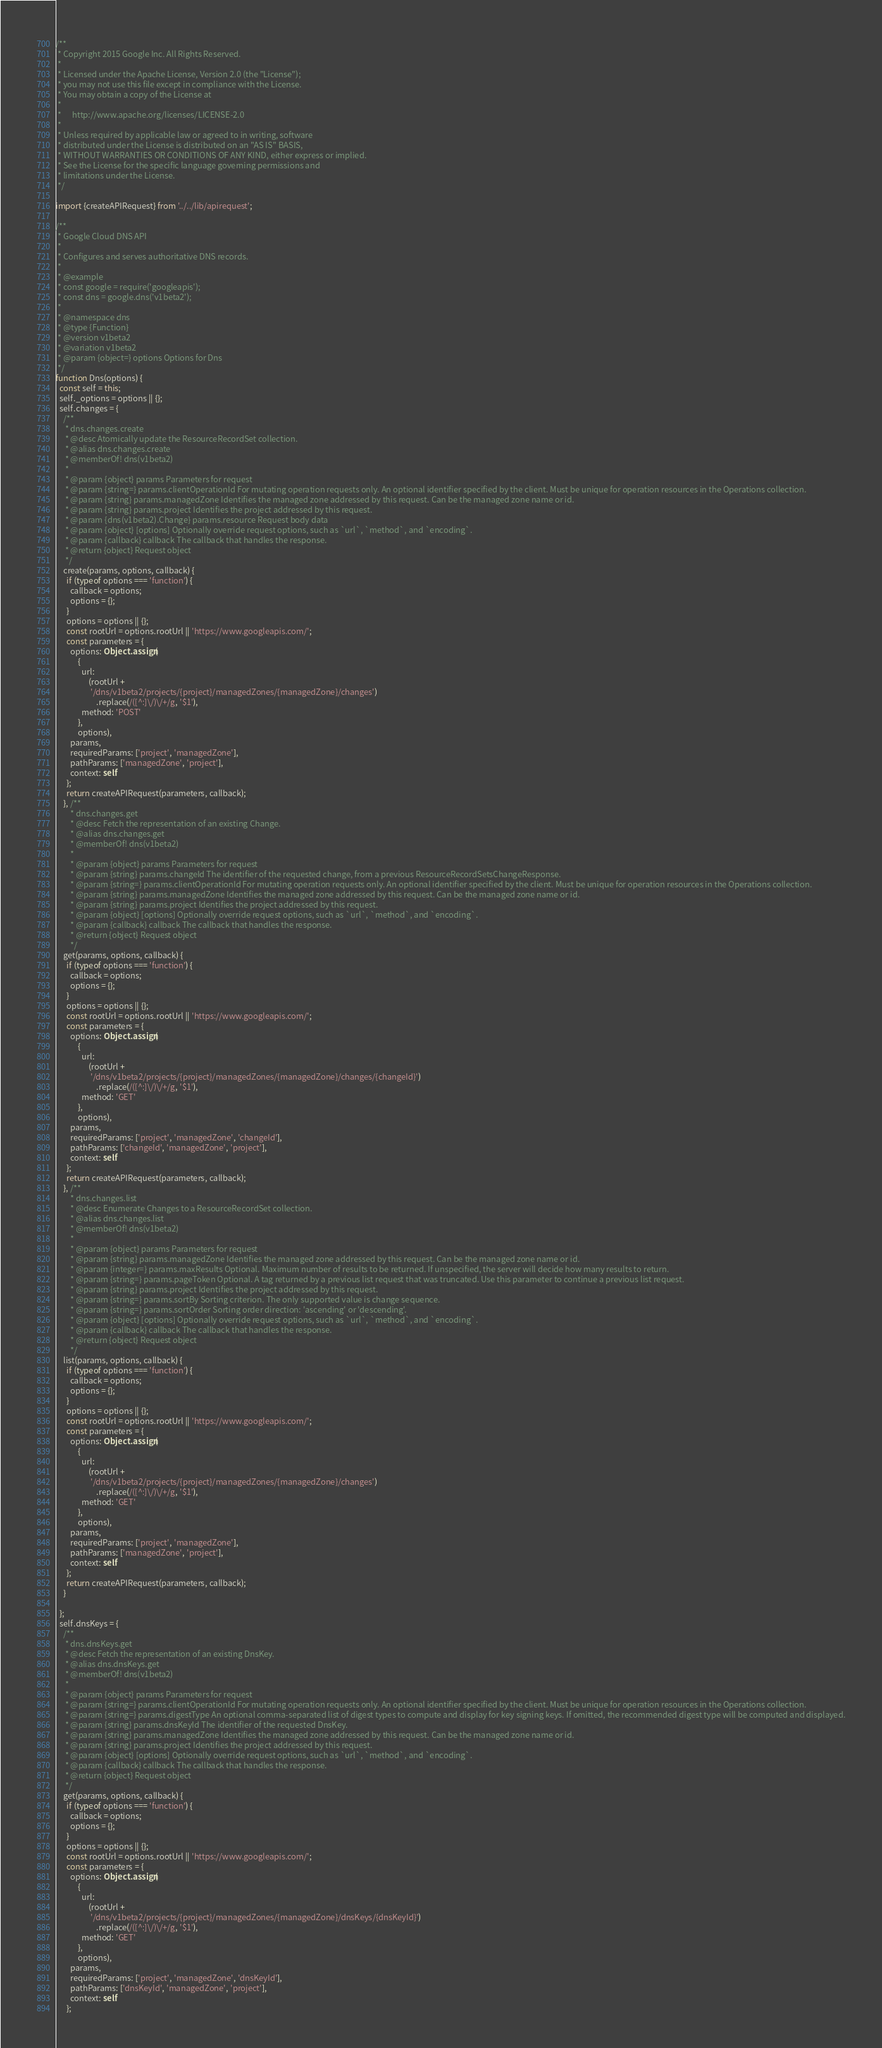Convert code to text. <code><loc_0><loc_0><loc_500><loc_500><_TypeScript_>/**
 * Copyright 2015 Google Inc. All Rights Reserved.
 *
 * Licensed under the Apache License, Version 2.0 (the "License");
 * you may not use this file except in compliance with the License.
 * You may obtain a copy of the License at
 *
 *      http://www.apache.org/licenses/LICENSE-2.0
 *
 * Unless required by applicable law or agreed to in writing, software
 * distributed under the License is distributed on an "AS IS" BASIS,
 * WITHOUT WARRANTIES OR CONDITIONS OF ANY KIND, either express or implied.
 * See the License for the specific language governing permissions and
 * limitations under the License.
 */

import {createAPIRequest} from '../../lib/apirequest';

/**
 * Google Cloud DNS API
 *
 * Configures and serves authoritative DNS records.
 *
 * @example
 * const google = require('googleapis');
 * const dns = google.dns('v1beta2');
 *
 * @namespace dns
 * @type {Function}
 * @version v1beta2
 * @variation v1beta2
 * @param {object=} options Options for Dns
 */
function Dns(options) {
  const self = this;
  self._options = options || {};
  self.changes = {
    /**
     * dns.changes.create
     * @desc Atomically update the ResourceRecordSet collection.
     * @alias dns.changes.create
     * @memberOf! dns(v1beta2)
     *
     * @param {object} params Parameters for request
     * @param {string=} params.clientOperationId For mutating operation requests only. An optional identifier specified by the client. Must be unique for operation resources in the Operations collection.
     * @param {string} params.managedZone Identifies the managed zone addressed by this request. Can be the managed zone name or id.
     * @param {string} params.project Identifies the project addressed by this request.
     * @param {dns(v1beta2).Change} params.resource Request body data
     * @param {object} [options] Optionally override request options, such as `url`, `method`, and `encoding`.
     * @param {callback} callback The callback that handles the response.
     * @return {object} Request object
     */
    create(params, options, callback) {
      if (typeof options === 'function') {
        callback = options;
        options = {};
      }
      options = options || {};
      const rootUrl = options.rootUrl || 'https://www.googleapis.com/';
      const parameters = {
        options: Object.assign(
            {
              url:
                  (rootUrl +
                   '/dns/v1beta2/projects/{project}/managedZones/{managedZone}/changes')
                      .replace(/([^:]\/)\/+/g, '$1'),
              method: 'POST'
            },
            options),
        params,
        requiredParams: ['project', 'managedZone'],
        pathParams: ['managedZone', 'project'],
        context: self
      };
      return createAPIRequest(parameters, callback);
    }, /**
        * dns.changes.get
        * @desc Fetch the representation of an existing Change.
        * @alias dns.changes.get
        * @memberOf! dns(v1beta2)
        *
        * @param {object} params Parameters for request
        * @param {string} params.changeId The identifier of the requested change, from a previous ResourceRecordSetsChangeResponse.
        * @param {string=} params.clientOperationId For mutating operation requests only. An optional identifier specified by the client. Must be unique for operation resources in the Operations collection.
        * @param {string} params.managedZone Identifies the managed zone addressed by this request. Can be the managed zone name or id.
        * @param {string} params.project Identifies the project addressed by this request.
        * @param {object} [options] Optionally override request options, such as `url`, `method`, and `encoding`.
        * @param {callback} callback The callback that handles the response.
        * @return {object} Request object
        */
    get(params, options, callback) {
      if (typeof options === 'function') {
        callback = options;
        options = {};
      }
      options = options || {};
      const rootUrl = options.rootUrl || 'https://www.googleapis.com/';
      const parameters = {
        options: Object.assign(
            {
              url:
                  (rootUrl +
                   '/dns/v1beta2/projects/{project}/managedZones/{managedZone}/changes/{changeId}')
                      .replace(/([^:]\/)\/+/g, '$1'),
              method: 'GET'
            },
            options),
        params,
        requiredParams: ['project', 'managedZone', 'changeId'],
        pathParams: ['changeId', 'managedZone', 'project'],
        context: self
      };
      return createAPIRequest(parameters, callback);
    }, /**
        * dns.changes.list
        * @desc Enumerate Changes to a ResourceRecordSet collection.
        * @alias dns.changes.list
        * @memberOf! dns(v1beta2)
        *
        * @param {object} params Parameters for request
        * @param {string} params.managedZone Identifies the managed zone addressed by this request. Can be the managed zone name or id.
        * @param {integer=} params.maxResults Optional. Maximum number of results to be returned. If unspecified, the server will decide how many results to return.
        * @param {string=} params.pageToken Optional. A tag returned by a previous list request that was truncated. Use this parameter to continue a previous list request.
        * @param {string} params.project Identifies the project addressed by this request.
        * @param {string=} params.sortBy Sorting criterion. The only supported value is change sequence.
        * @param {string=} params.sortOrder Sorting order direction: 'ascending' or 'descending'.
        * @param {object} [options] Optionally override request options, such as `url`, `method`, and `encoding`.
        * @param {callback} callback The callback that handles the response.
        * @return {object} Request object
        */
    list(params, options, callback) {
      if (typeof options === 'function') {
        callback = options;
        options = {};
      }
      options = options || {};
      const rootUrl = options.rootUrl || 'https://www.googleapis.com/';
      const parameters = {
        options: Object.assign(
            {
              url:
                  (rootUrl +
                   '/dns/v1beta2/projects/{project}/managedZones/{managedZone}/changes')
                      .replace(/([^:]\/)\/+/g, '$1'),
              method: 'GET'
            },
            options),
        params,
        requiredParams: ['project', 'managedZone'],
        pathParams: ['managedZone', 'project'],
        context: self
      };
      return createAPIRequest(parameters, callback);
    }

  };
  self.dnsKeys = {
    /**
     * dns.dnsKeys.get
     * @desc Fetch the representation of an existing DnsKey.
     * @alias dns.dnsKeys.get
     * @memberOf! dns(v1beta2)
     *
     * @param {object} params Parameters for request
     * @param {string=} params.clientOperationId For mutating operation requests only. An optional identifier specified by the client. Must be unique for operation resources in the Operations collection.
     * @param {string=} params.digestType An optional comma-separated list of digest types to compute and display for key signing keys. If omitted, the recommended digest type will be computed and displayed.
     * @param {string} params.dnsKeyId The identifier of the requested DnsKey.
     * @param {string} params.managedZone Identifies the managed zone addressed by this request. Can be the managed zone name or id.
     * @param {string} params.project Identifies the project addressed by this request.
     * @param {object} [options] Optionally override request options, such as `url`, `method`, and `encoding`.
     * @param {callback} callback The callback that handles the response.
     * @return {object} Request object
     */
    get(params, options, callback) {
      if (typeof options === 'function') {
        callback = options;
        options = {};
      }
      options = options || {};
      const rootUrl = options.rootUrl || 'https://www.googleapis.com/';
      const parameters = {
        options: Object.assign(
            {
              url:
                  (rootUrl +
                   '/dns/v1beta2/projects/{project}/managedZones/{managedZone}/dnsKeys/{dnsKeyId}')
                      .replace(/([^:]\/)\/+/g, '$1'),
              method: 'GET'
            },
            options),
        params,
        requiredParams: ['project', 'managedZone', 'dnsKeyId'],
        pathParams: ['dnsKeyId', 'managedZone', 'project'],
        context: self
      };</code> 